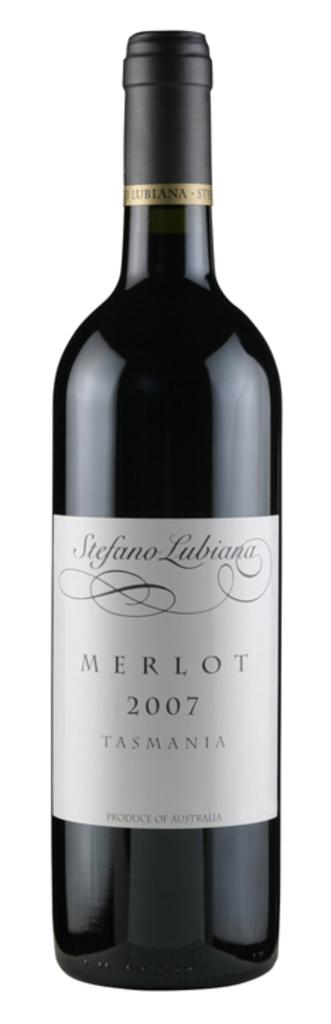What year was the wine bottled?
Offer a very short reply. 2007. What is the name of this wine?
Provide a succinct answer. Merlot. 